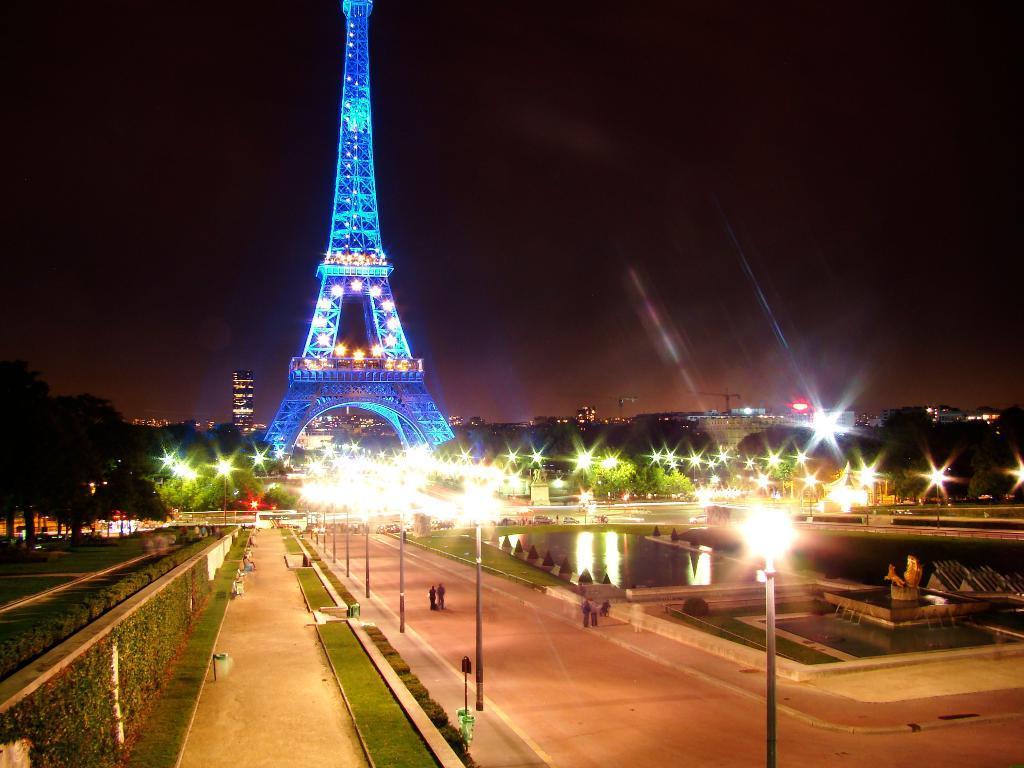Describe this image in one or two sentences. In this image we can see the roads, walls, grass, light poles, water, trees, Eiffel tower with lights, buildings and the dark sky in the background. 